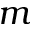<formula> <loc_0><loc_0><loc_500><loc_500>m</formula> 